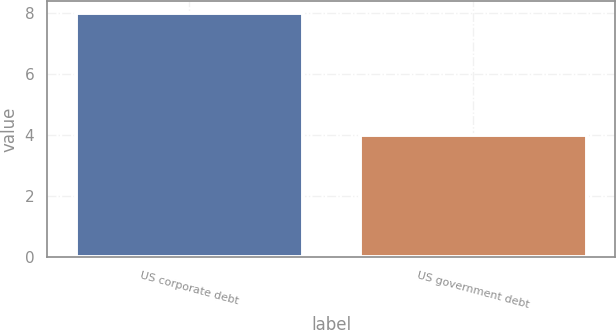Convert chart. <chart><loc_0><loc_0><loc_500><loc_500><bar_chart><fcel>US corporate debt<fcel>US government debt<nl><fcel>8<fcel>4<nl></chart> 